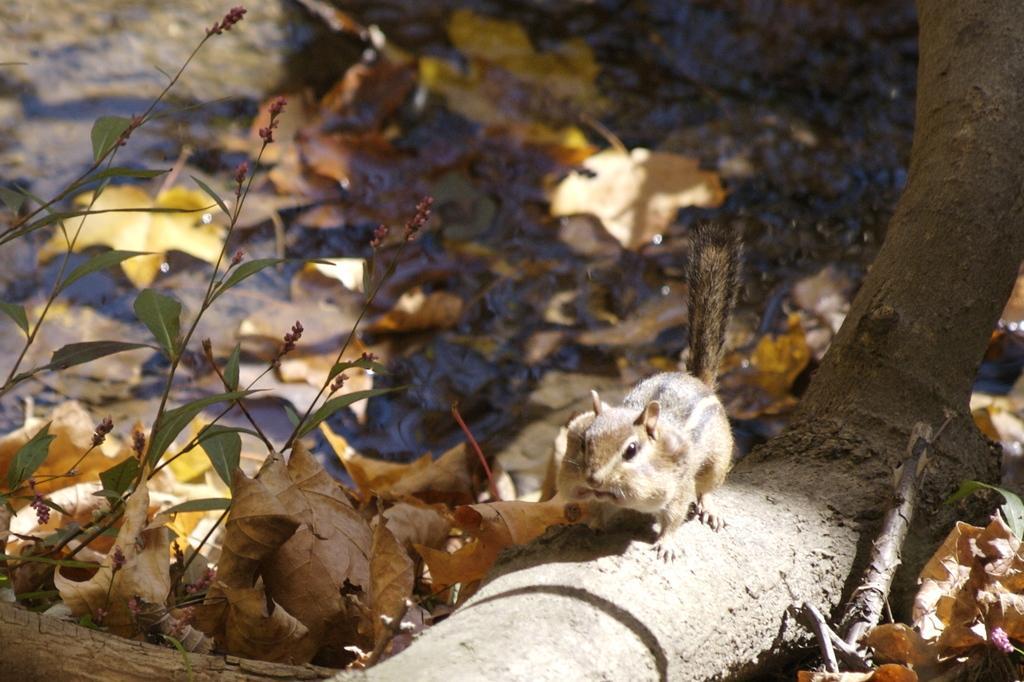Describe this image in one or two sentences. In this image we can see a squirrel on a tree trunk. On the ground there are dried leaves. Also there are few plants. 